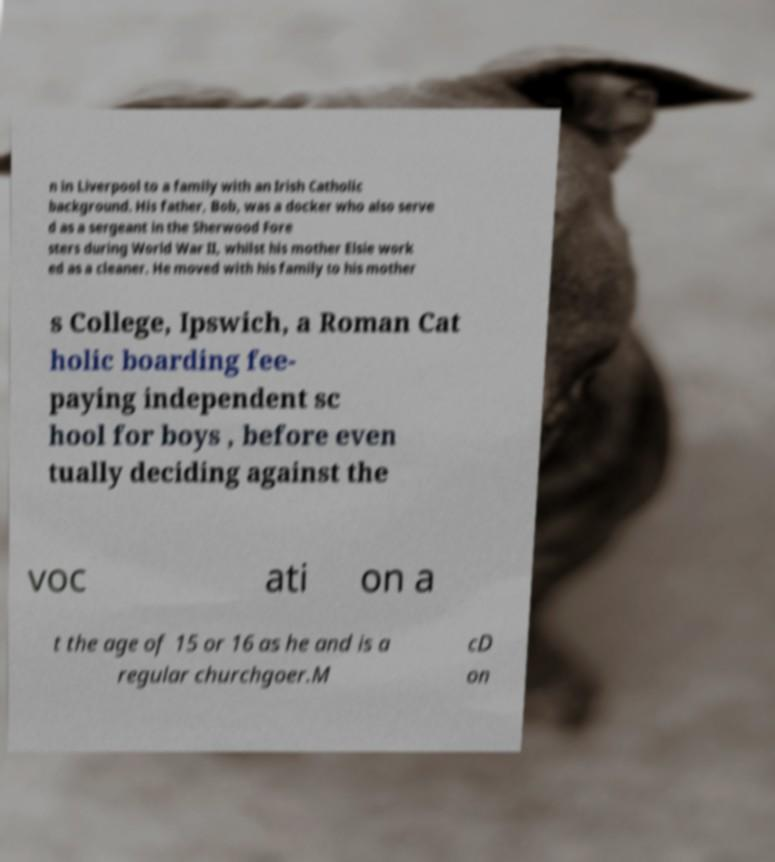Can you read and provide the text displayed in the image?This photo seems to have some interesting text. Can you extract and type it out for me? n in Liverpool to a family with an Irish Catholic background. His father, Bob, was a docker who also serve d as a sergeant in the Sherwood Fore sters during World War II, whilst his mother Elsie work ed as a cleaner. He moved with his family to his mother s College, Ipswich, a Roman Cat holic boarding fee- paying independent sc hool for boys , before even tually deciding against the voc ati on a t the age of 15 or 16 as he and is a regular churchgoer.M cD on 